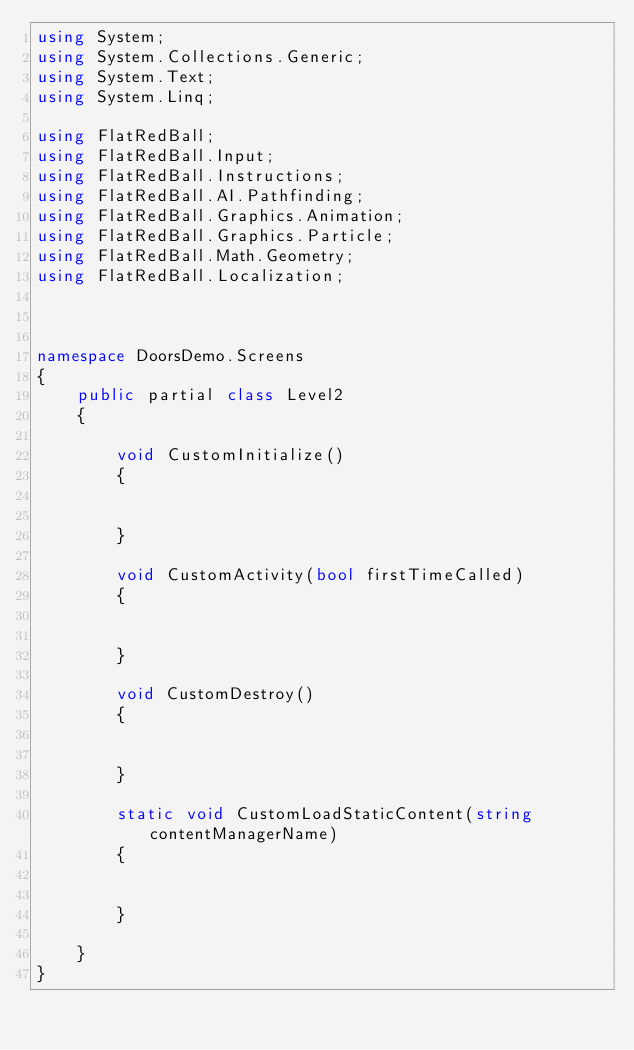<code> <loc_0><loc_0><loc_500><loc_500><_C#_>using System;
using System.Collections.Generic;
using System.Text;
using System.Linq;

using FlatRedBall;
using FlatRedBall.Input;
using FlatRedBall.Instructions;
using FlatRedBall.AI.Pathfinding;
using FlatRedBall.Graphics.Animation;
using FlatRedBall.Graphics.Particle;
using FlatRedBall.Math.Geometry;
using FlatRedBall.Localization;



namespace DoorsDemo.Screens
{
    public partial class Level2
    {

        void CustomInitialize()
        {


        }

        void CustomActivity(bool firstTimeCalled)
        {


        }

        void CustomDestroy()
        {


        }

        static void CustomLoadStaticContent(string contentManagerName)
        {


        }

    }
}
</code> 